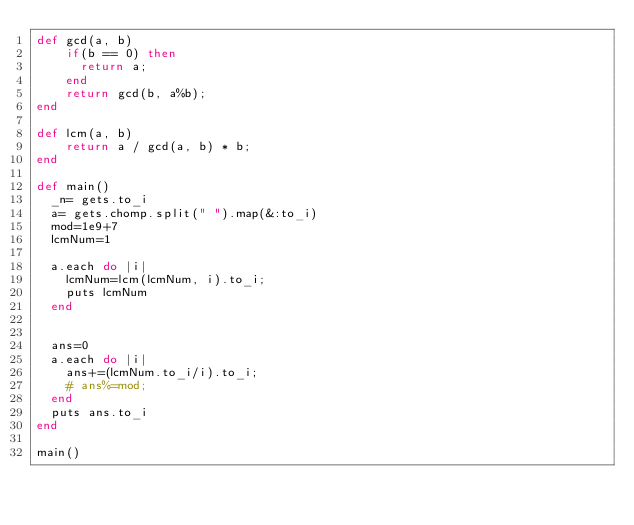Convert code to text. <code><loc_0><loc_0><loc_500><loc_500><_Ruby_>def gcd(a, b)
    if(b == 0) then
      return a;
    end
    return gcd(b, a%b);
end

def lcm(a, b) 
    return a / gcd(a, b) * b;
end

def main()
  _n= gets.to_i
  a= gets.chomp.split(" ").map(&:to_i)
  mod=1e9+7
  lcmNum=1
  
  a.each do |i|
    lcmNum=lcm(lcmNum, i).to_i;
    puts lcmNum
  end

  
  ans=0
  a.each do |i|
    ans+=(lcmNum.to_i/i).to_i;
    # ans%=mod; 
  end
  puts ans.to_i
end

main()
</code> 